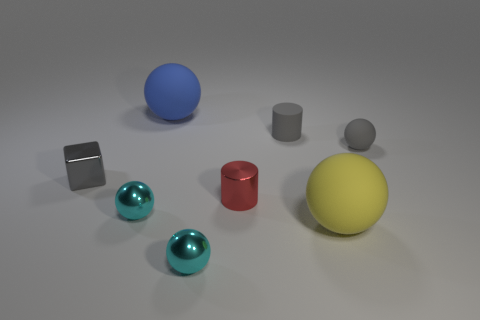How would you describe the lighting in this scene? The lighting in the scene is soft and diffused, coming from above. It creates gentle shadows under the objects, which helps give a sense of depth and dimension to the arrangement without harsh contrasts. 